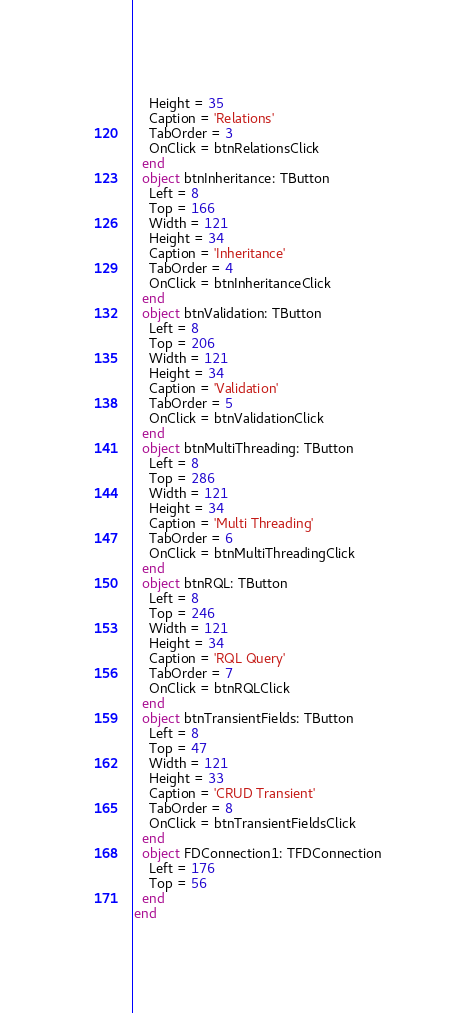<code> <loc_0><loc_0><loc_500><loc_500><_Pascal_>    Height = 35
    Caption = 'Relations'
    TabOrder = 3
    OnClick = btnRelationsClick
  end
  object btnInheritance: TButton
    Left = 8
    Top = 166
    Width = 121
    Height = 34
    Caption = 'Inheritance'
    TabOrder = 4
    OnClick = btnInheritanceClick
  end
  object btnValidation: TButton
    Left = 8
    Top = 206
    Width = 121
    Height = 34
    Caption = 'Validation'
    TabOrder = 5
    OnClick = btnValidationClick
  end
  object btnMultiThreading: TButton
    Left = 8
    Top = 286
    Width = 121
    Height = 34
    Caption = 'Multi Threading'
    TabOrder = 6
    OnClick = btnMultiThreadingClick
  end
  object btnRQL: TButton
    Left = 8
    Top = 246
    Width = 121
    Height = 34
    Caption = 'RQL Query'
    TabOrder = 7
    OnClick = btnRQLClick
  end
  object btnTransientFields: TButton
    Left = 8
    Top = 47
    Width = 121
    Height = 33
    Caption = 'CRUD Transient'
    TabOrder = 8
    OnClick = btnTransientFieldsClick
  end
  object FDConnection1: TFDConnection
    Left = 176
    Top = 56
  end
end
</code> 